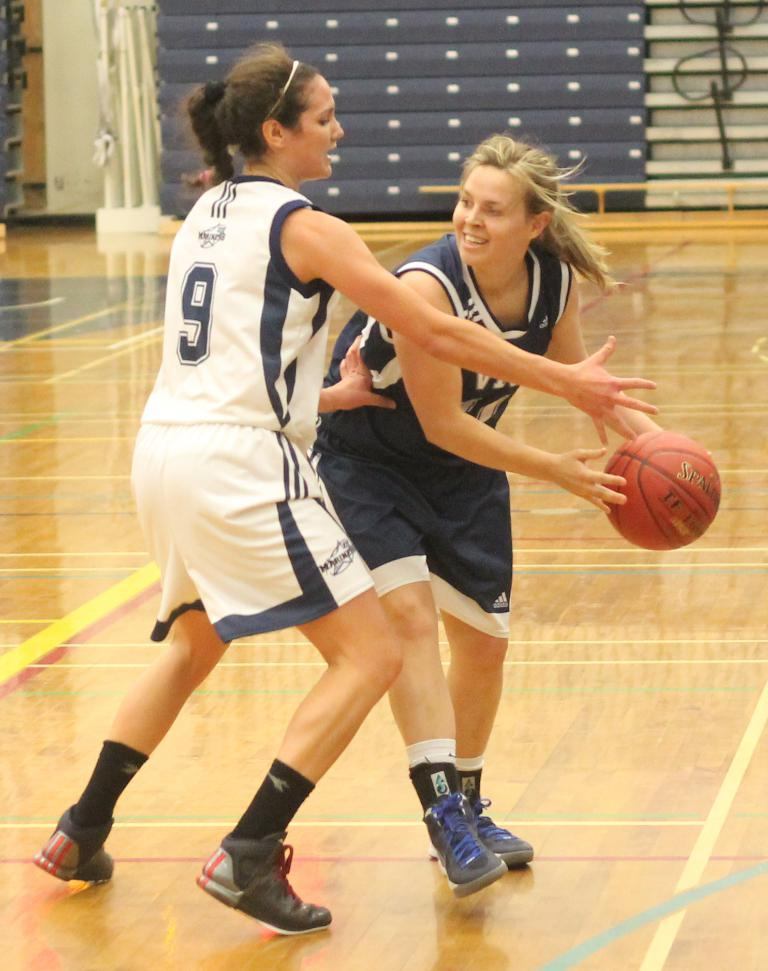<image>
Summarize the visual content of the image. a couple of women playing a game of basketball one with the number 9 